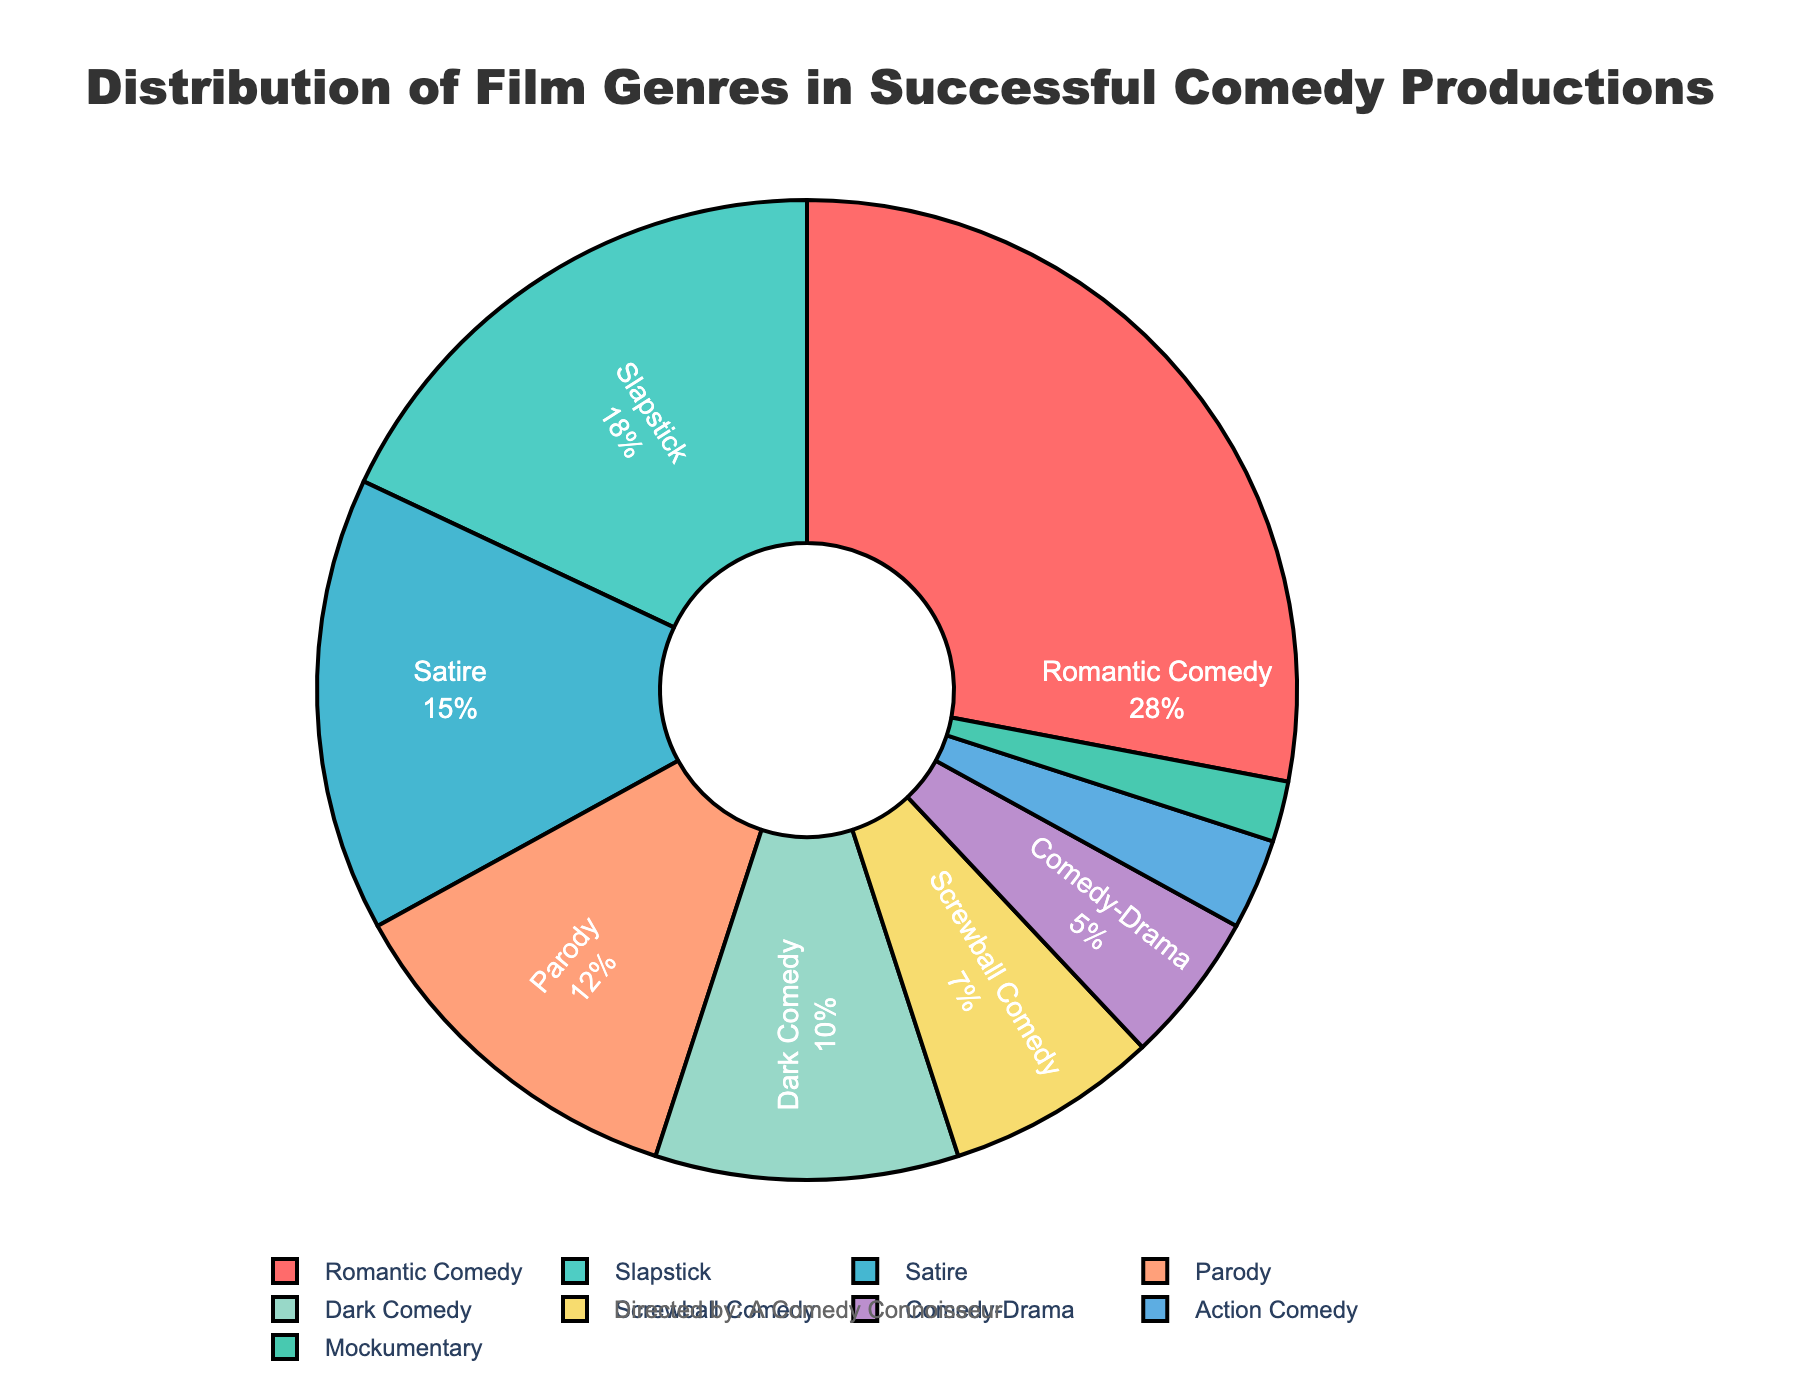What genre holds the largest percentage of successful comedy productions? The largest percentage can be identified by looking for the biggest slice in the pie chart. The 'Romantic Comedy' genre occupies the largest slice at 28%.
Answer: Romantic Comedy What is the combined percentage of Slapstick and Parody genres? To find the combined percentage, sum the values of 'Slapstick' (18%) and 'Parody' (12%). 18% + 12% = 30%.
Answer: 30% How does the percentage of Dark Comedy compare to that of Satire? Compare the percentages of 'Dark Comedy' (10%) and 'Satire' (15%). Since 10% is less than 15%, 'Dark Comedy' has a lower percentage.
Answer: Less Which genre is the least represented in successful comedy productions? The least represented genre can be found by identifying the smallest slice in the pie chart, which is 'Mockumentary' with a slice of 2%.
Answer: Mockumentary What is the total percentage of the three least represented genres? Sum the percentages of 'Comedy-Drama' (5%), 'Action Comedy' (3%), and 'Mockumentary' (2%). 5% + 3% + 2% = 10%.
Answer: 10% By how much does the percentage of Romantic Comedy exceed the percentage of Satire? Subtract the percentage of 'Satire' (15%) from 'Romantic Comedy' (28%). 28% - 15% = 13%.
Answer: 13% What is the difference in percentage between Satire and Screwball Comedy? Subtract the percentage of 'Screwball Comedy' (7%) from 'Satire' (15%). 15% - 7% = 8%.
Answer: 8% Which genre segments are colored red and green, respectively? Observe the pie chart and identify the corresponding colors for each segment. 'Romantic Comedy' is red and 'Slapstick' is green.
Answer: Romantic Comedy and Slapstick What is the ratio of percentages between Parody and Mockumentary? Divide the percentage of 'Parody' (12%) by that of 'Mockumentary' (2%). 12 / 2 = 6.
Answer: 6:1 How many genres have a percentage greater than or equal to 10%? Identify slices whose percentages are 10% or more: 'Romantic Comedy' (28%), 'Slapstick' (18%), 'Satire' (15%), and 'Dark Comedy' (10%). There are 4 genres.
Answer: 4 